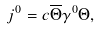<formula> <loc_0><loc_0><loc_500><loc_500>j ^ { 0 } = c \overline { \Theta } \gamma ^ { 0 } \Theta ,</formula> 